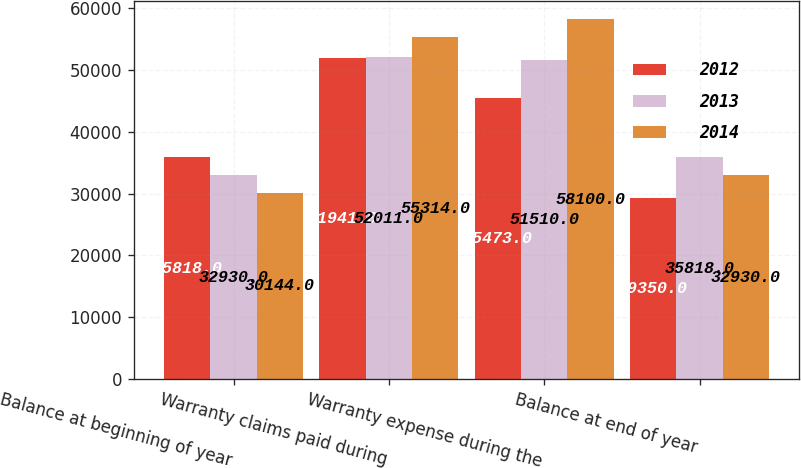Convert chart. <chart><loc_0><loc_0><loc_500><loc_500><stacked_bar_chart><ecel><fcel>Balance at beginning of year<fcel>Warranty claims paid during<fcel>Warranty expense during the<fcel>Balance at end of year<nl><fcel>2012<fcel>35818<fcel>51941<fcel>45473<fcel>29350<nl><fcel>2013<fcel>32930<fcel>52011<fcel>51510<fcel>35818<nl><fcel>2014<fcel>30144<fcel>55314<fcel>58100<fcel>32930<nl></chart> 